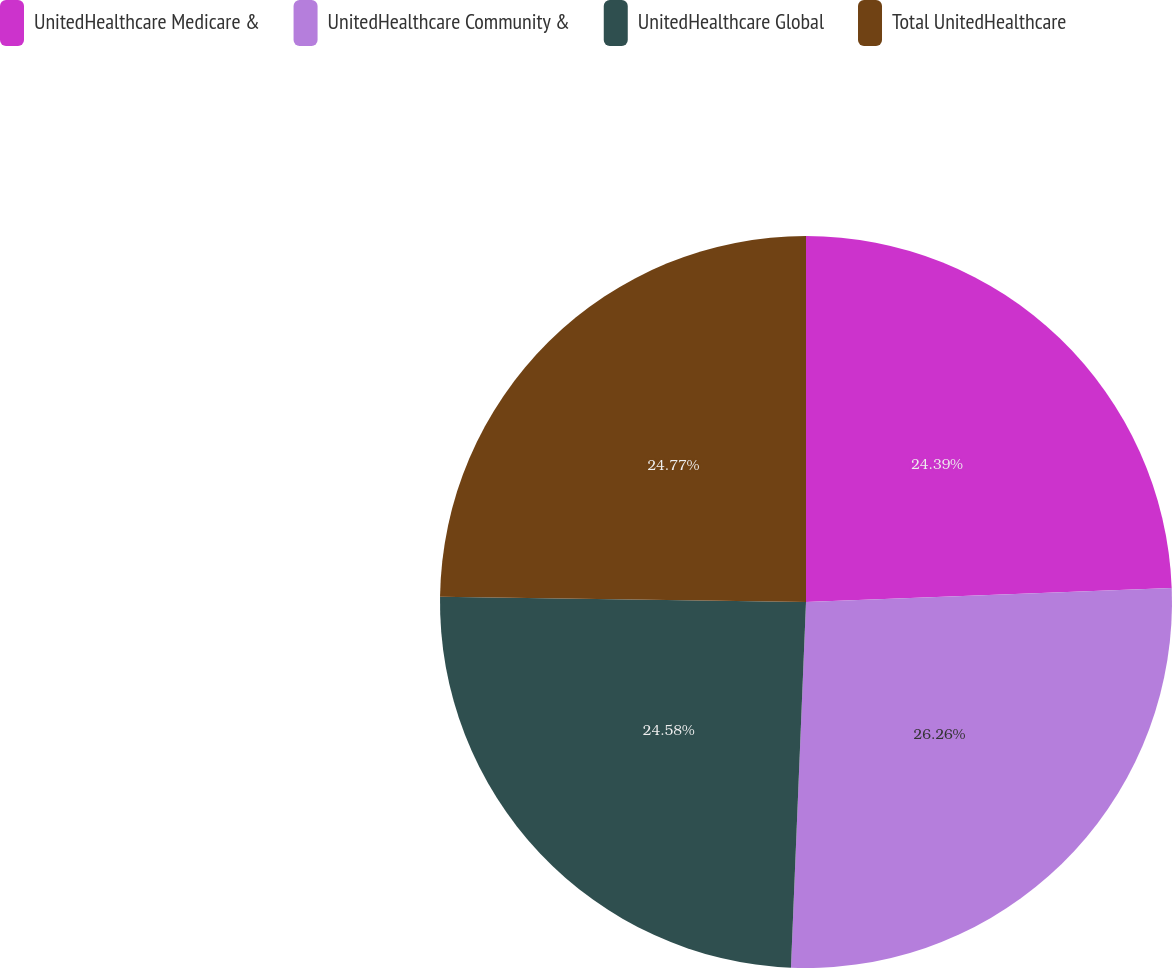<chart> <loc_0><loc_0><loc_500><loc_500><pie_chart><fcel>UnitedHealthcare Medicare &<fcel>UnitedHealthcare Community &<fcel>UnitedHealthcare Global<fcel>Total UnitedHealthcare<nl><fcel>24.39%<fcel>26.27%<fcel>24.58%<fcel>24.77%<nl></chart> 